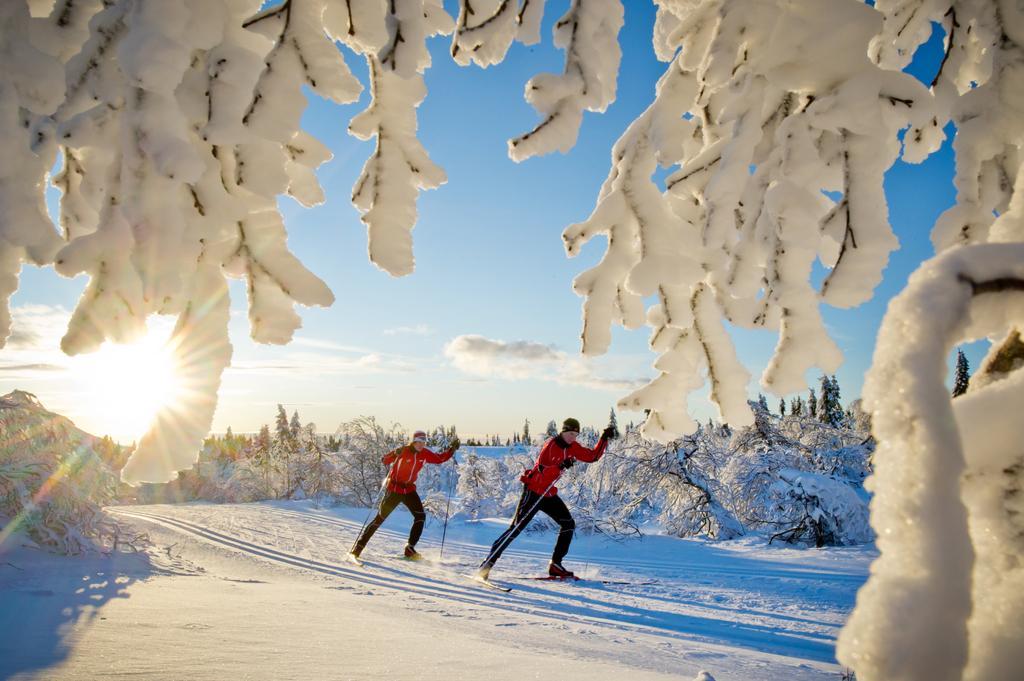Can you describe this image briefly? In this picture I can see there are two people wearing skis and holding the ski sticks and there is snow on the floor and the trees are also covered with the snow and the sky is clear and sunny. 